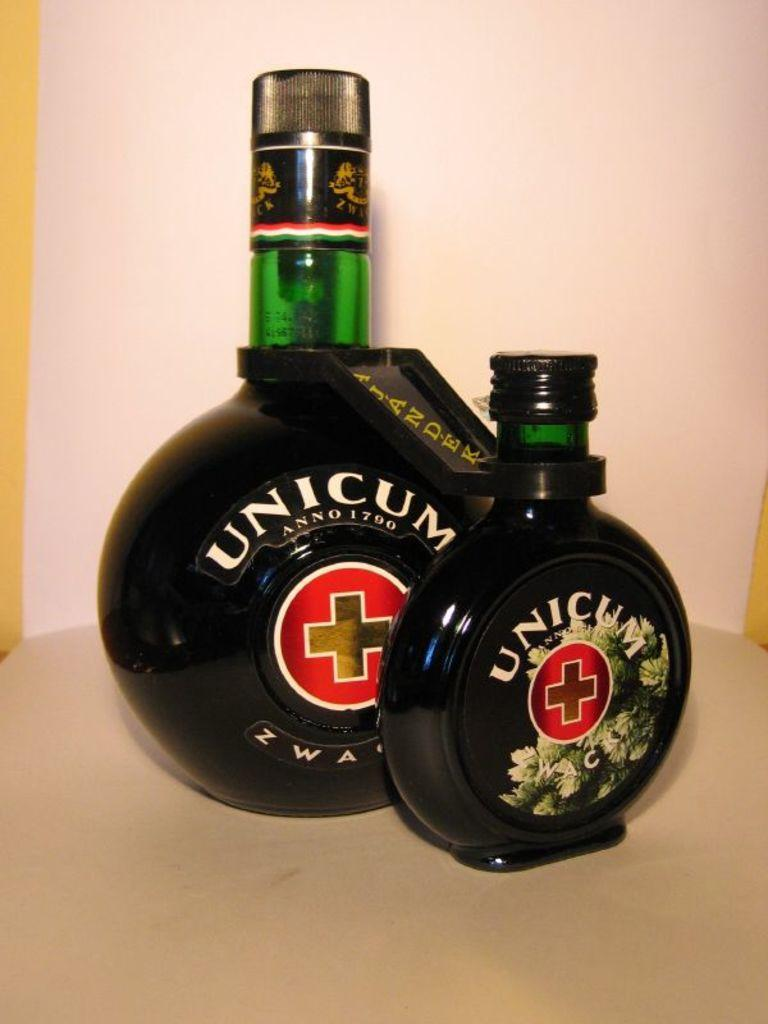<image>
Render a clear and concise summary of the photo. Two bottles in different sizes by Unicum have a red circle on the label. 